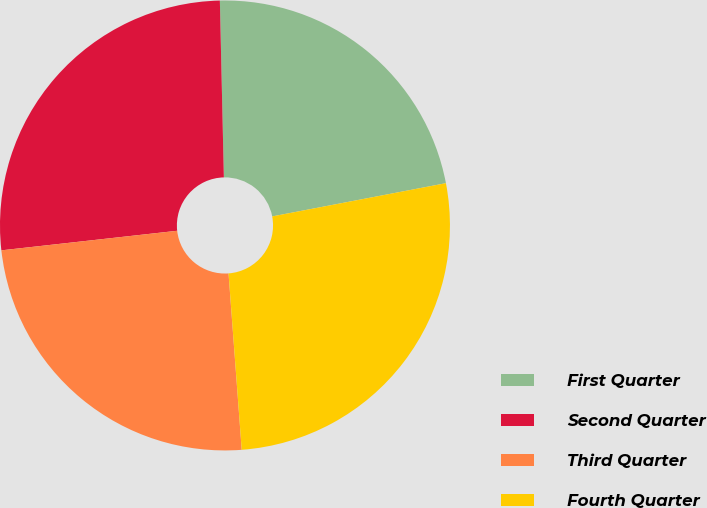Convert chart. <chart><loc_0><loc_0><loc_500><loc_500><pie_chart><fcel>First Quarter<fcel>Second Quarter<fcel>Third Quarter<fcel>Fourth Quarter<nl><fcel>22.35%<fcel>26.4%<fcel>24.42%<fcel>26.82%<nl></chart> 